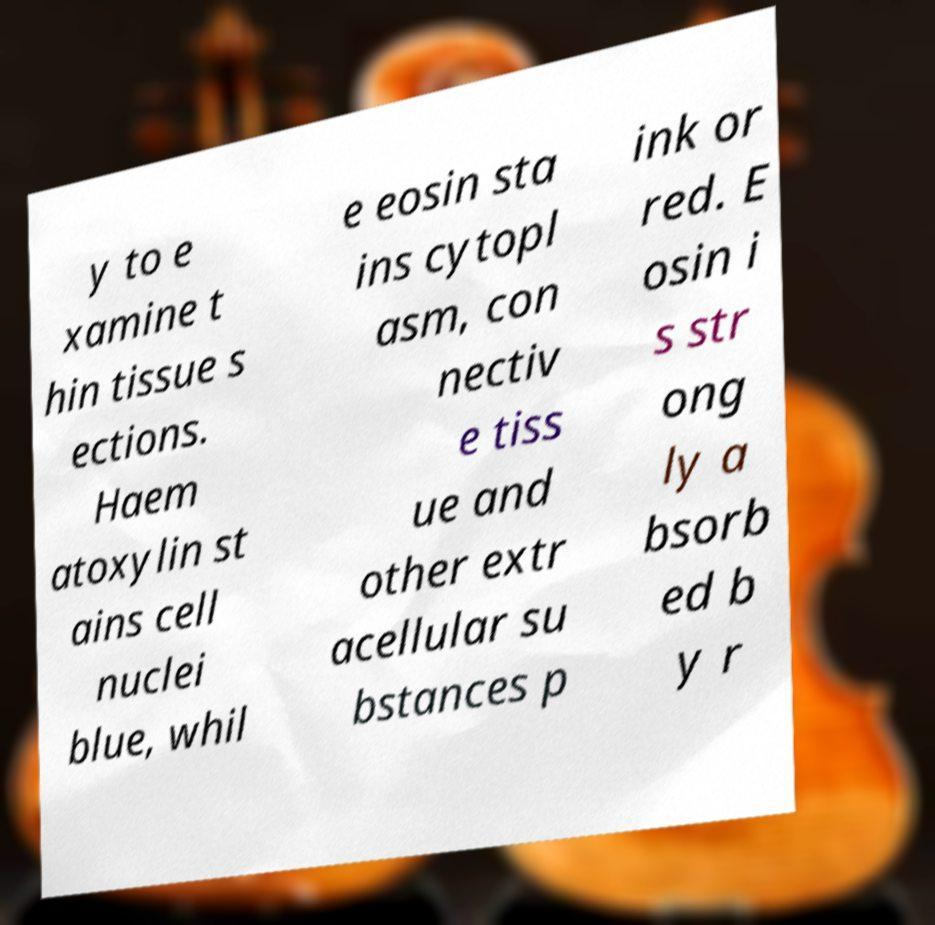There's text embedded in this image that I need extracted. Can you transcribe it verbatim? y to e xamine t hin tissue s ections. Haem atoxylin st ains cell nuclei blue, whil e eosin sta ins cytopl asm, con nectiv e tiss ue and other extr acellular su bstances p ink or red. E osin i s str ong ly a bsorb ed b y r 